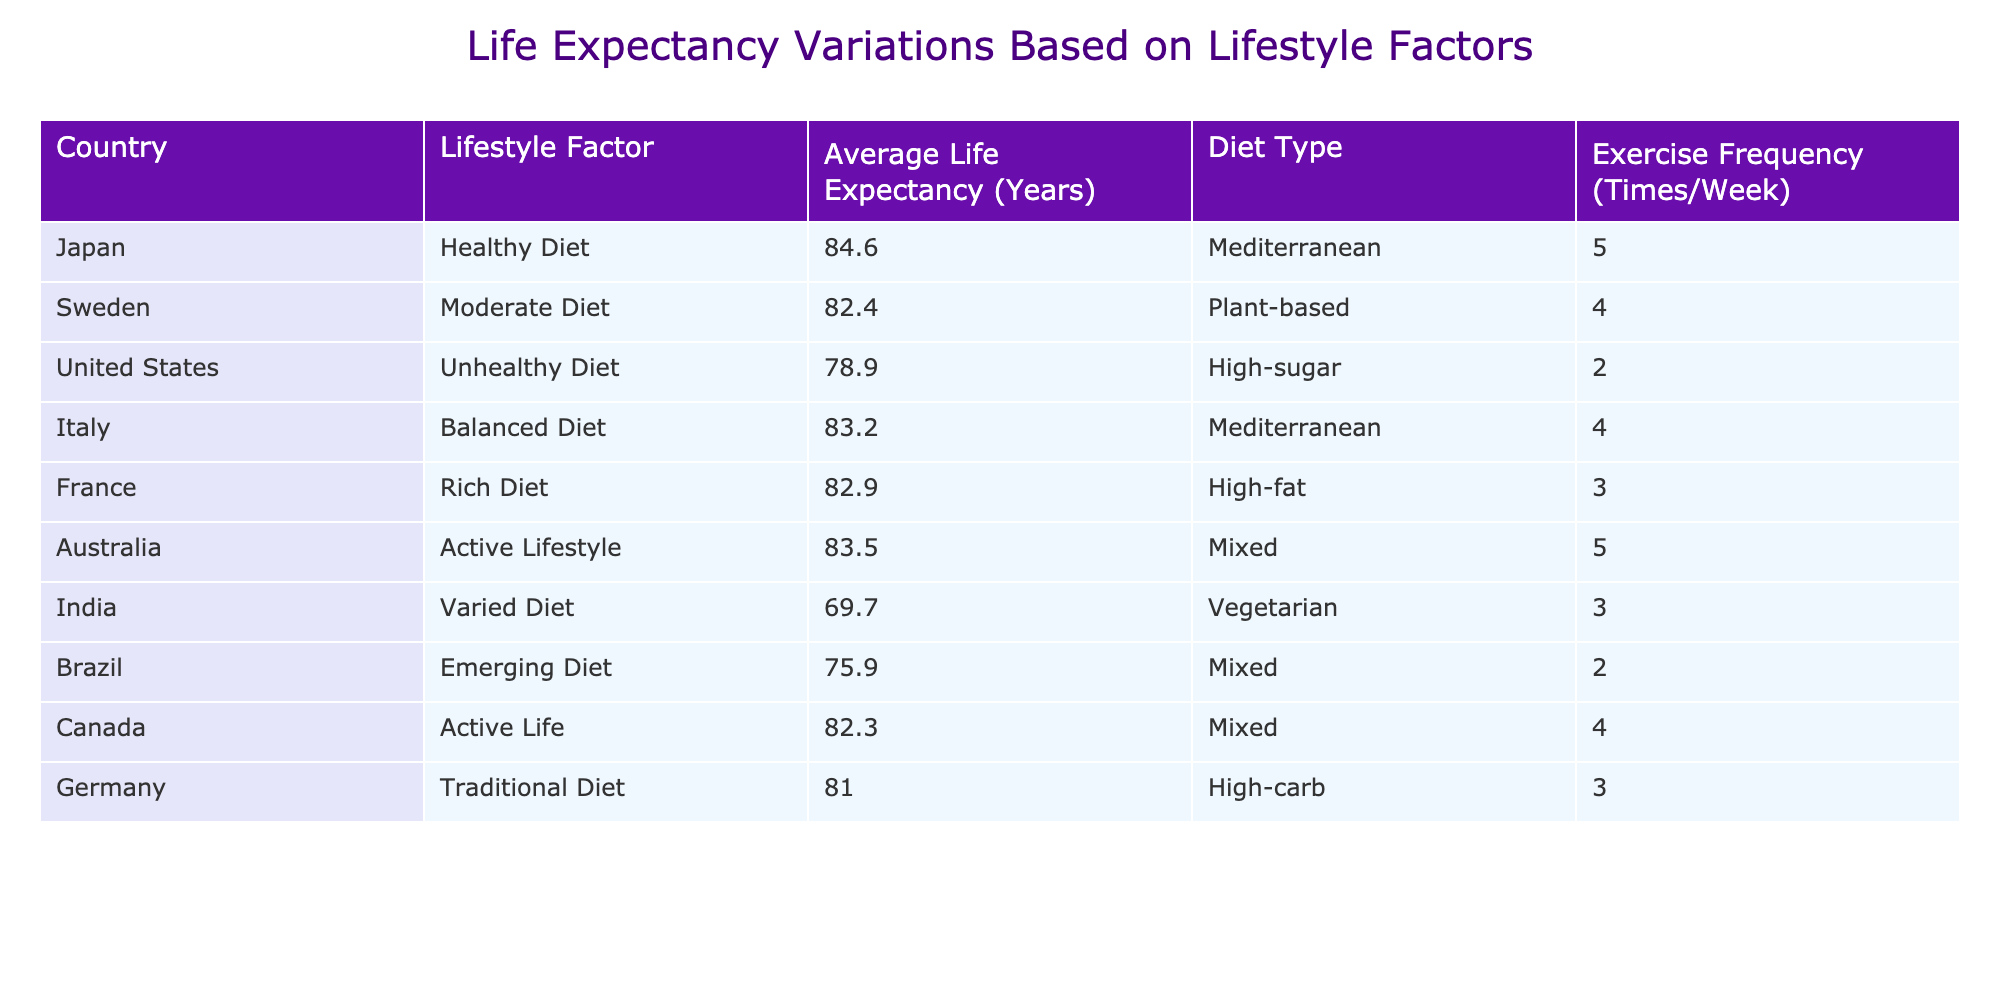What is the average life expectancy for countries with a healthy diet? The only country listed with a healthy diet is Japan, which has an average life expectancy of 84.6 years. Therefore, the average life expectancy for this group is simply 84.6 years.
Answer: 84.6 Which country has the highest average life expectancy? Looking at the table, Japan has the highest life expectancy at 84.6 years.
Answer: Japan Is it true that countries with an active lifestyle have an average life expectancy above 80 years? The active lifestyle countries listed are Australia (83.5 years) and Canada (82.3 years). Averaging these gives (83.5 + 82.3) / 2 = 82.9 years, which is above 80. Therefore, the statement is true.
Answer: Yes What is the difference in life expectancy between the healthiest and the unhealthiest diet? The healthiest diet is found in Japan with 84.6 years, while the unhealthiest is the United States with 78.9 years. The difference is 84.6 - 78.9 = 5.7 years.
Answer: 5.7 Do all countries with a Mediterranean diet have a life expectancy over 80 years? The Mediterranean diet countries are Japan (84.6 years) and Italy (83.2 years). Both have life expectancies over 80 years. Therefore, the statement is true.
Answer: Yes What is the average exercise frequency for countries with a rich diet? France is the only country with a rich diet, exercising 3 times a week. Thus, the average exercise frequency for this group is 3.
Answer: 3 Which country with a varied diet has the lowest average life expectancy? The only country with a varied diet listed is India, which has an average life expectancy of 69.7 years, making it the lowest for this category.
Answer: India If we consider all the countries listed, which diet type has the best average life expectancy? The dietary types and their respective life expectancies are: Mediterranean (84.6, 83.2), Plant-based (82.4), High-sugar (78.9), High-fat (82.9), Vegetarian (69.7), Mixed (83.5, 75.9), and High-carb (81.0). The average for Mediterranean is (84.6 + 83.2) / 2 = 83.9 years, which is the highest overall.
Answer: Mediterranean 